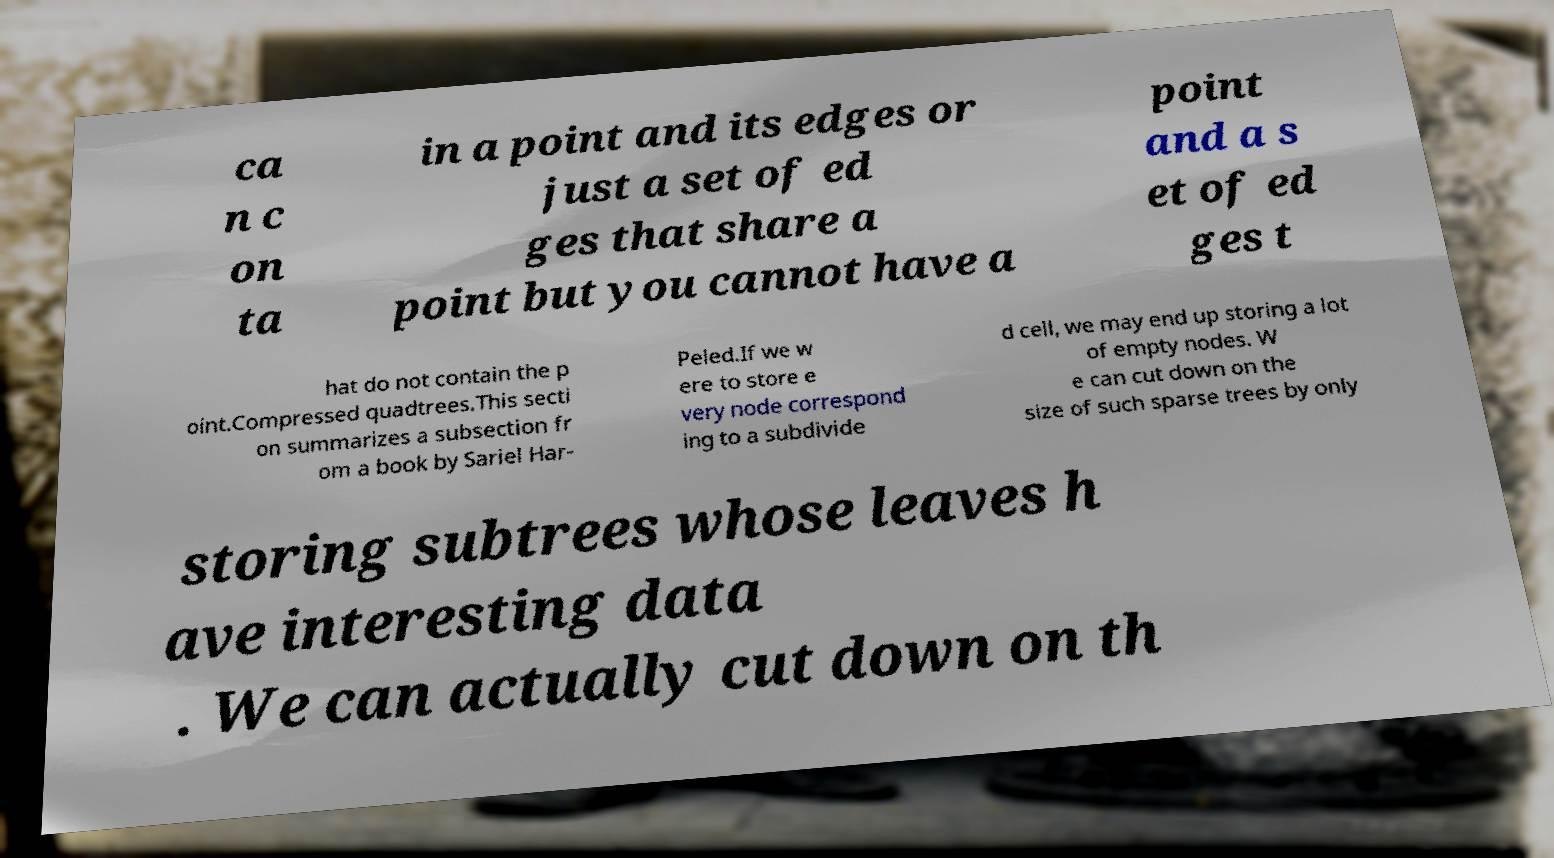Could you extract and type out the text from this image? ca n c on ta in a point and its edges or just a set of ed ges that share a point but you cannot have a point and a s et of ed ges t hat do not contain the p oint.Compressed quadtrees.This secti on summarizes a subsection fr om a book by Sariel Har- Peled.If we w ere to store e very node correspond ing to a subdivide d cell, we may end up storing a lot of empty nodes. W e can cut down on the size of such sparse trees by only storing subtrees whose leaves h ave interesting data . We can actually cut down on th 